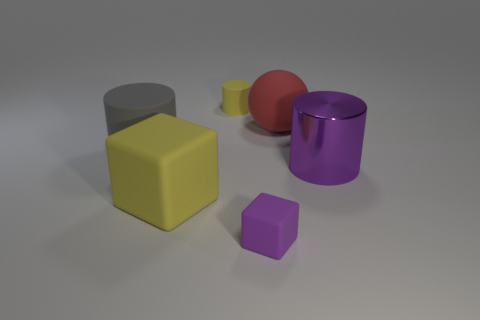What is the material of the big cylinder that is on the right side of the red sphere?
Provide a succinct answer. Metal. How many other things are the same size as the red thing?
Your response must be concise. 3. There is a gray cylinder; does it have the same size as the matte block on the right side of the yellow cylinder?
Provide a short and direct response. No. What shape is the big object that is behind the large cylinder that is left of the yellow object behind the big yellow rubber thing?
Your answer should be very brief. Sphere. Is the number of small red blocks less than the number of gray rubber cylinders?
Provide a succinct answer. Yes. Are there any purple rubber cubes behind the big purple metal cylinder?
Give a very brief answer. No. What is the shape of the big matte thing that is behind the large rubber cube and to the left of the big red rubber thing?
Offer a terse response. Cylinder. Is there another large metallic object of the same shape as the metallic object?
Your answer should be compact. No. There is a purple shiny cylinder that is right of the gray rubber thing; is its size the same as the cylinder behind the large gray rubber object?
Your response must be concise. No. Are there more small cyan cubes than big red balls?
Provide a succinct answer. No. 